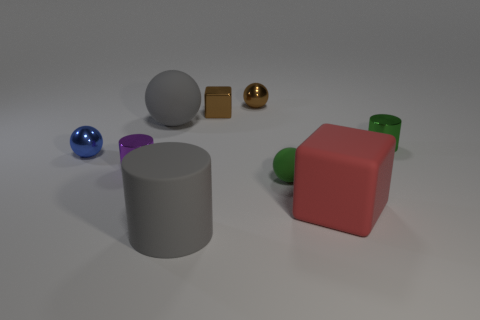Subtract all big spheres. How many spheres are left? 3 Subtract 1 balls. How many balls are left? 3 Add 1 small shiny cubes. How many objects exist? 10 Subtract all gray cylinders. How many cylinders are left? 2 Subtract all red spheres. Subtract all brown cylinders. How many spheres are left? 4 Add 6 small purple cylinders. How many small purple cylinders are left? 7 Add 2 large gray metallic balls. How many large gray metallic balls exist? 2 Subtract 0 red cylinders. How many objects are left? 9 Subtract all cubes. How many objects are left? 7 Subtract all purple things. Subtract all large red matte cubes. How many objects are left? 7 